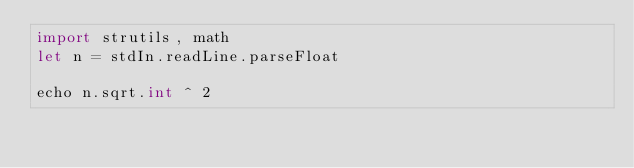<code> <loc_0><loc_0><loc_500><loc_500><_Nim_>import strutils, math
let n = stdIn.readLine.parseFloat

echo n.sqrt.int ^ 2
</code> 